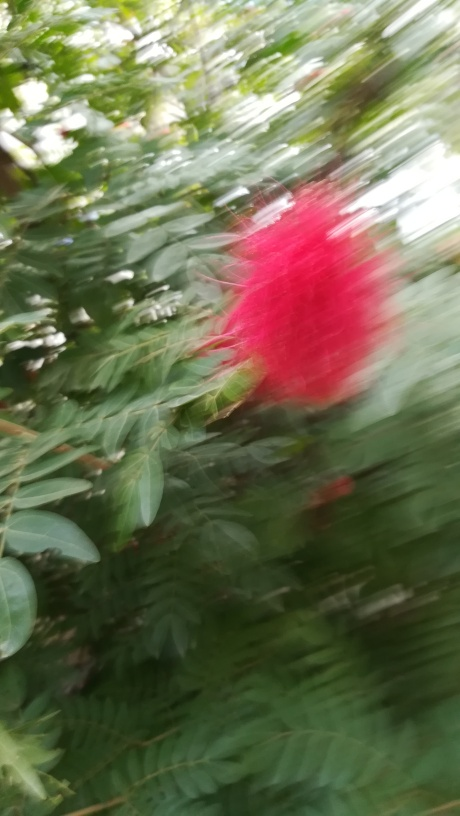Is there a specific reason why this image may have been captured despite the blur? It's possible the image was captured in haste to document a fleeting moment, such as wildlife interaction or a gust of wind affecting the plant. Alternatively, the photographer might have intended to capture the vibrant color or unique form of the plant, despite the unfavorable conditions for a clear shot. 